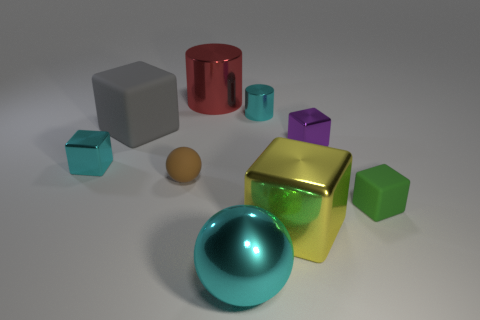Subtract 1 blocks. How many blocks are left? 4 Subtract all green cubes. How many cubes are left? 4 Subtract all green cubes. How many cubes are left? 4 Subtract all blue blocks. Subtract all red cylinders. How many blocks are left? 5 Add 1 big yellow things. How many objects exist? 10 Subtract all blocks. How many objects are left? 4 Subtract all small cylinders. Subtract all small cyan cubes. How many objects are left? 7 Add 5 big rubber objects. How many big rubber objects are left? 6 Add 7 large yellow spheres. How many large yellow spheres exist? 7 Subtract 0 brown cubes. How many objects are left? 9 